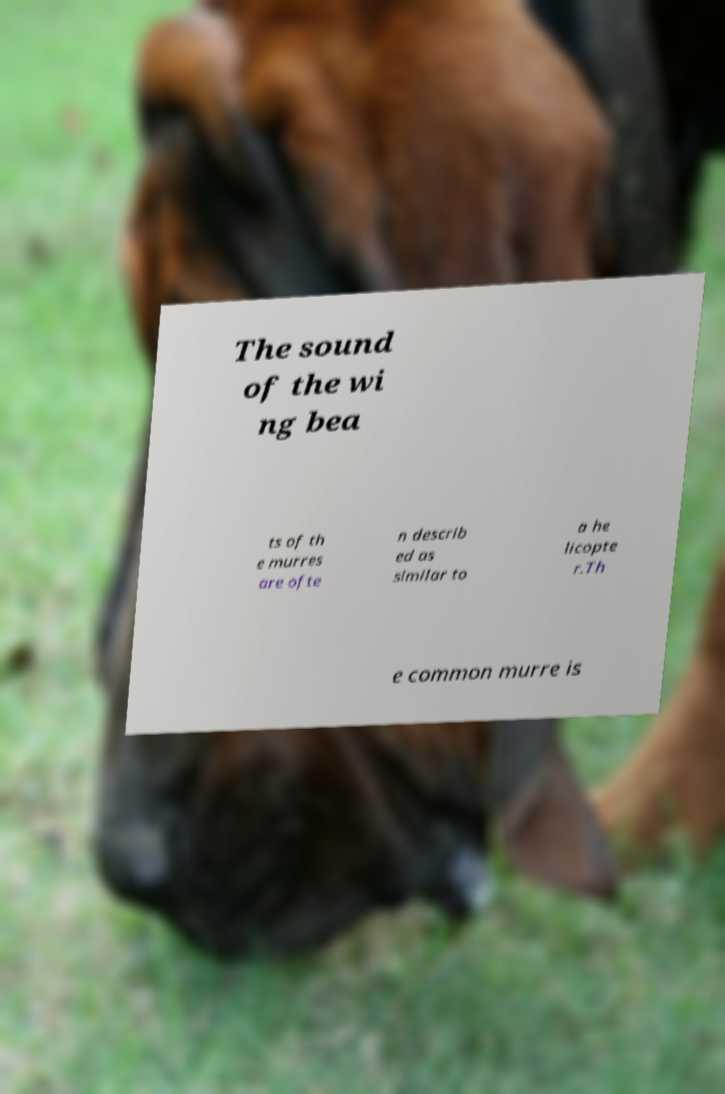Please read and relay the text visible in this image. What does it say? The sound of the wi ng bea ts of th e murres are ofte n describ ed as similar to a he licopte r.Th e common murre is 